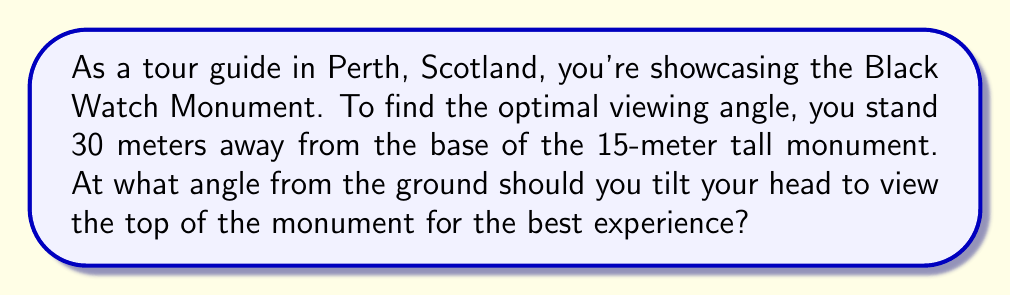Show me your answer to this math problem. Let's approach this step-by-step using trigonometry:

1) First, we need to visualize the problem:

   [asy]
   import geometry;
   
   size(200);
   
   pair A = (0,0);
   pair B = (30,0);
   pair C = (30,15);
   
   draw(A--B--C--A);
   
   label("30m", (15,0), S);
   label("15m", (30,7.5), E);
   label("θ", (0,0), NW);
   
   draw(arc(B,1,0,degrees(atan2(15,30))),Arrow);
   [/asy]

2) We have a right-angled triangle where:
   - The adjacent side is 30 meters (distance from viewer to monument base)
   - The opposite side is 15 meters (height of the monument)
   - We need to find the angle θ

3) In this case, we can use the tangent function:

   $$\tan(\theta) = \frac{\text{opposite}}{\text{adjacent}} = \frac{15}{30} = \frac{1}{2}$$

4) To find θ, we need to use the inverse tangent (arctan or $\tan^{-1}$):

   $$\theta = \tan^{-1}(\frac{1}{2})$$

5) Using a calculator or mathematical software:

   $$\theta \approx 26.57°$$

6) This angle (approximately 26.57°) represents the optimal viewing angle from the ground to the top of the monument.
Answer: $26.57°$ 